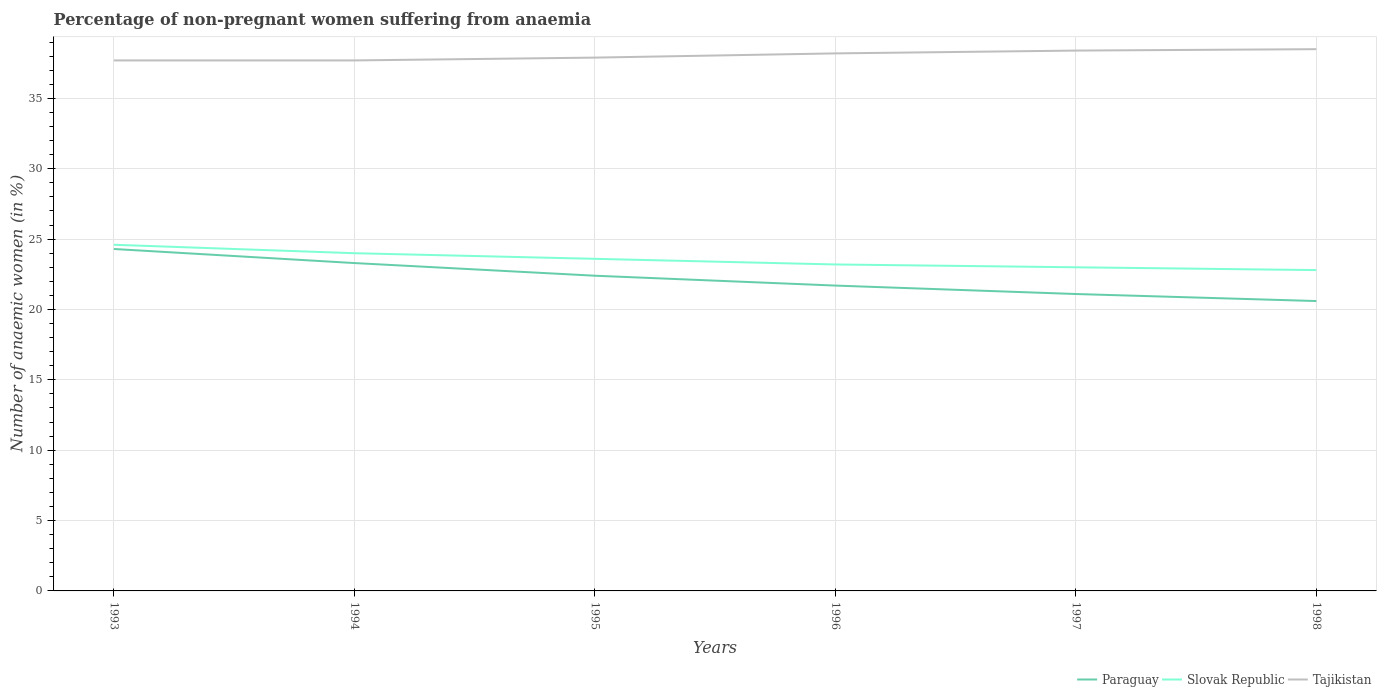Is the number of lines equal to the number of legend labels?
Give a very brief answer. Yes. Across all years, what is the maximum percentage of non-pregnant women suffering from anaemia in Paraguay?
Give a very brief answer. 20.6. In which year was the percentage of non-pregnant women suffering from anaemia in Slovak Republic maximum?
Keep it short and to the point. 1998. What is the total percentage of non-pregnant women suffering from anaemia in Paraguay in the graph?
Offer a terse response. 1.9. What is the difference between the highest and the second highest percentage of non-pregnant women suffering from anaemia in Slovak Republic?
Your answer should be compact. 1.8. What is the difference between the highest and the lowest percentage of non-pregnant women suffering from anaemia in Tajikistan?
Keep it short and to the point. 3. How many years are there in the graph?
Offer a terse response. 6. What is the difference between two consecutive major ticks on the Y-axis?
Your answer should be very brief. 5. Does the graph contain grids?
Offer a terse response. Yes. Where does the legend appear in the graph?
Keep it short and to the point. Bottom right. How many legend labels are there?
Your answer should be compact. 3. What is the title of the graph?
Ensure brevity in your answer.  Percentage of non-pregnant women suffering from anaemia. Does "Honduras" appear as one of the legend labels in the graph?
Make the answer very short. No. What is the label or title of the X-axis?
Your response must be concise. Years. What is the label or title of the Y-axis?
Offer a very short reply. Number of anaemic women (in %). What is the Number of anaemic women (in %) in Paraguay in 1993?
Make the answer very short. 24.3. What is the Number of anaemic women (in %) of Slovak Republic in 1993?
Make the answer very short. 24.6. What is the Number of anaemic women (in %) of Tajikistan in 1993?
Your answer should be very brief. 37.7. What is the Number of anaemic women (in %) of Paraguay in 1994?
Provide a short and direct response. 23.3. What is the Number of anaemic women (in %) in Tajikistan in 1994?
Make the answer very short. 37.7. What is the Number of anaemic women (in %) in Paraguay in 1995?
Your answer should be compact. 22.4. What is the Number of anaemic women (in %) in Slovak Republic in 1995?
Offer a terse response. 23.6. What is the Number of anaemic women (in %) in Tajikistan in 1995?
Offer a very short reply. 37.9. What is the Number of anaemic women (in %) of Paraguay in 1996?
Provide a short and direct response. 21.7. What is the Number of anaemic women (in %) of Slovak Republic in 1996?
Make the answer very short. 23.2. What is the Number of anaemic women (in %) in Tajikistan in 1996?
Your answer should be very brief. 38.2. What is the Number of anaemic women (in %) of Paraguay in 1997?
Keep it short and to the point. 21.1. What is the Number of anaemic women (in %) in Tajikistan in 1997?
Provide a short and direct response. 38.4. What is the Number of anaemic women (in %) of Paraguay in 1998?
Keep it short and to the point. 20.6. What is the Number of anaemic women (in %) of Slovak Republic in 1998?
Ensure brevity in your answer.  22.8. What is the Number of anaemic women (in %) of Tajikistan in 1998?
Provide a succinct answer. 38.5. Across all years, what is the maximum Number of anaemic women (in %) in Paraguay?
Your answer should be compact. 24.3. Across all years, what is the maximum Number of anaemic women (in %) in Slovak Republic?
Make the answer very short. 24.6. Across all years, what is the maximum Number of anaemic women (in %) of Tajikistan?
Your answer should be very brief. 38.5. Across all years, what is the minimum Number of anaemic women (in %) in Paraguay?
Keep it short and to the point. 20.6. Across all years, what is the minimum Number of anaemic women (in %) of Slovak Republic?
Give a very brief answer. 22.8. Across all years, what is the minimum Number of anaemic women (in %) of Tajikistan?
Your answer should be compact. 37.7. What is the total Number of anaemic women (in %) in Paraguay in the graph?
Your answer should be compact. 133.4. What is the total Number of anaemic women (in %) of Slovak Republic in the graph?
Your response must be concise. 141.2. What is the total Number of anaemic women (in %) of Tajikistan in the graph?
Make the answer very short. 228.4. What is the difference between the Number of anaemic women (in %) of Paraguay in 1993 and that in 1994?
Provide a short and direct response. 1. What is the difference between the Number of anaemic women (in %) in Slovak Republic in 1993 and that in 1995?
Make the answer very short. 1. What is the difference between the Number of anaemic women (in %) in Tajikistan in 1993 and that in 1996?
Give a very brief answer. -0.5. What is the difference between the Number of anaemic women (in %) in Paraguay in 1993 and that in 1997?
Make the answer very short. 3.2. What is the difference between the Number of anaemic women (in %) in Slovak Republic in 1993 and that in 1997?
Make the answer very short. 1.6. What is the difference between the Number of anaemic women (in %) of Tajikistan in 1993 and that in 1997?
Provide a short and direct response. -0.7. What is the difference between the Number of anaemic women (in %) in Slovak Republic in 1993 and that in 1998?
Your response must be concise. 1.8. What is the difference between the Number of anaemic women (in %) in Paraguay in 1994 and that in 1995?
Give a very brief answer. 0.9. What is the difference between the Number of anaemic women (in %) in Slovak Republic in 1994 and that in 1995?
Your answer should be compact. 0.4. What is the difference between the Number of anaemic women (in %) of Tajikistan in 1994 and that in 1996?
Provide a short and direct response. -0.5. What is the difference between the Number of anaemic women (in %) in Slovak Republic in 1994 and that in 1997?
Give a very brief answer. 1. What is the difference between the Number of anaemic women (in %) in Tajikistan in 1994 and that in 1997?
Your answer should be compact. -0.7. What is the difference between the Number of anaemic women (in %) in Tajikistan in 1994 and that in 1998?
Ensure brevity in your answer.  -0.8. What is the difference between the Number of anaemic women (in %) of Paraguay in 1995 and that in 1997?
Offer a very short reply. 1.3. What is the difference between the Number of anaemic women (in %) of Paraguay in 1995 and that in 1998?
Make the answer very short. 1.8. What is the difference between the Number of anaemic women (in %) in Slovak Republic in 1995 and that in 1998?
Ensure brevity in your answer.  0.8. What is the difference between the Number of anaemic women (in %) of Tajikistan in 1996 and that in 1997?
Your answer should be compact. -0.2. What is the difference between the Number of anaemic women (in %) in Slovak Republic in 1996 and that in 1998?
Your answer should be compact. 0.4. What is the difference between the Number of anaemic women (in %) of Paraguay in 1993 and the Number of anaemic women (in %) of Tajikistan in 1994?
Provide a succinct answer. -13.4. What is the difference between the Number of anaemic women (in %) in Slovak Republic in 1993 and the Number of anaemic women (in %) in Tajikistan in 1994?
Your response must be concise. -13.1. What is the difference between the Number of anaemic women (in %) in Paraguay in 1993 and the Number of anaemic women (in %) in Tajikistan in 1995?
Your response must be concise. -13.6. What is the difference between the Number of anaemic women (in %) in Slovak Republic in 1993 and the Number of anaemic women (in %) in Tajikistan in 1995?
Your answer should be compact. -13.3. What is the difference between the Number of anaemic women (in %) in Paraguay in 1993 and the Number of anaemic women (in %) in Slovak Republic in 1996?
Your response must be concise. 1.1. What is the difference between the Number of anaemic women (in %) in Slovak Republic in 1993 and the Number of anaemic women (in %) in Tajikistan in 1996?
Your answer should be very brief. -13.6. What is the difference between the Number of anaemic women (in %) of Paraguay in 1993 and the Number of anaemic women (in %) of Slovak Republic in 1997?
Offer a very short reply. 1.3. What is the difference between the Number of anaemic women (in %) of Paraguay in 1993 and the Number of anaemic women (in %) of Tajikistan in 1997?
Your response must be concise. -14.1. What is the difference between the Number of anaemic women (in %) of Slovak Republic in 1993 and the Number of anaemic women (in %) of Tajikistan in 1998?
Keep it short and to the point. -13.9. What is the difference between the Number of anaemic women (in %) in Paraguay in 1994 and the Number of anaemic women (in %) in Slovak Republic in 1995?
Provide a succinct answer. -0.3. What is the difference between the Number of anaemic women (in %) of Paraguay in 1994 and the Number of anaemic women (in %) of Tajikistan in 1995?
Ensure brevity in your answer.  -14.6. What is the difference between the Number of anaemic women (in %) of Slovak Republic in 1994 and the Number of anaemic women (in %) of Tajikistan in 1995?
Provide a succinct answer. -13.9. What is the difference between the Number of anaemic women (in %) of Paraguay in 1994 and the Number of anaemic women (in %) of Slovak Republic in 1996?
Keep it short and to the point. 0.1. What is the difference between the Number of anaemic women (in %) of Paraguay in 1994 and the Number of anaemic women (in %) of Tajikistan in 1996?
Your response must be concise. -14.9. What is the difference between the Number of anaemic women (in %) in Slovak Republic in 1994 and the Number of anaemic women (in %) in Tajikistan in 1996?
Make the answer very short. -14.2. What is the difference between the Number of anaemic women (in %) of Paraguay in 1994 and the Number of anaemic women (in %) of Slovak Republic in 1997?
Your answer should be very brief. 0.3. What is the difference between the Number of anaemic women (in %) of Paraguay in 1994 and the Number of anaemic women (in %) of Tajikistan in 1997?
Offer a very short reply. -15.1. What is the difference between the Number of anaemic women (in %) of Slovak Republic in 1994 and the Number of anaemic women (in %) of Tajikistan in 1997?
Your answer should be compact. -14.4. What is the difference between the Number of anaemic women (in %) of Paraguay in 1994 and the Number of anaemic women (in %) of Slovak Republic in 1998?
Provide a short and direct response. 0.5. What is the difference between the Number of anaemic women (in %) of Paraguay in 1994 and the Number of anaemic women (in %) of Tajikistan in 1998?
Make the answer very short. -15.2. What is the difference between the Number of anaemic women (in %) of Slovak Republic in 1994 and the Number of anaemic women (in %) of Tajikistan in 1998?
Provide a short and direct response. -14.5. What is the difference between the Number of anaemic women (in %) in Paraguay in 1995 and the Number of anaemic women (in %) in Tajikistan in 1996?
Make the answer very short. -15.8. What is the difference between the Number of anaemic women (in %) of Slovak Republic in 1995 and the Number of anaemic women (in %) of Tajikistan in 1996?
Provide a succinct answer. -14.6. What is the difference between the Number of anaemic women (in %) of Paraguay in 1995 and the Number of anaemic women (in %) of Slovak Republic in 1997?
Provide a short and direct response. -0.6. What is the difference between the Number of anaemic women (in %) in Paraguay in 1995 and the Number of anaemic women (in %) in Tajikistan in 1997?
Provide a succinct answer. -16. What is the difference between the Number of anaemic women (in %) in Slovak Republic in 1995 and the Number of anaemic women (in %) in Tajikistan in 1997?
Your answer should be compact. -14.8. What is the difference between the Number of anaemic women (in %) in Paraguay in 1995 and the Number of anaemic women (in %) in Slovak Republic in 1998?
Offer a very short reply. -0.4. What is the difference between the Number of anaemic women (in %) of Paraguay in 1995 and the Number of anaemic women (in %) of Tajikistan in 1998?
Your answer should be compact. -16.1. What is the difference between the Number of anaemic women (in %) in Slovak Republic in 1995 and the Number of anaemic women (in %) in Tajikistan in 1998?
Give a very brief answer. -14.9. What is the difference between the Number of anaemic women (in %) in Paraguay in 1996 and the Number of anaemic women (in %) in Slovak Republic in 1997?
Make the answer very short. -1.3. What is the difference between the Number of anaemic women (in %) of Paraguay in 1996 and the Number of anaemic women (in %) of Tajikistan in 1997?
Your answer should be compact. -16.7. What is the difference between the Number of anaemic women (in %) in Slovak Republic in 1996 and the Number of anaemic women (in %) in Tajikistan in 1997?
Provide a succinct answer. -15.2. What is the difference between the Number of anaemic women (in %) of Paraguay in 1996 and the Number of anaemic women (in %) of Tajikistan in 1998?
Your answer should be very brief. -16.8. What is the difference between the Number of anaemic women (in %) of Slovak Republic in 1996 and the Number of anaemic women (in %) of Tajikistan in 1998?
Ensure brevity in your answer.  -15.3. What is the difference between the Number of anaemic women (in %) of Paraguay in 1997 and the Number of anaemic women (in %) of Slovak Republic in 1998?
Offer a very short reply. -1.7. What is the difference between the Number of anaemic women (in %) in Paraguay in 1997 and the Number of anaemic women (in %) in Tajikistan in 1998?
Your answer should be compact. -17.4. What is the difference between the Number of anaemic women (in %) in Slovak Republic in 1997 and the Number of anaemic women (in %) in Tajikistan in 1998?
Give a very brief answer. -15.5. What is the average Number of anaemic women (in %) of Paraguay per year?
Your response must be concise. 22.23. What is the average Number of anaemic women (in %) in Slovak Republic per year?
Make the answer very short. 23.53. What is the average Number of anaemic women (in %) in Tajikistan per year?
Your answer should be very brief. 38.07. In the year 1993, what is the difference between the Number of anaemic women (in %) of Paraguay and Number of anaemic women (in %) of Slovak Republic?
Your answer should be very brief. -0.3. In the year 1993, what is the difference between the Number of anaemic women (in %) in Slovak Republic and Number of anaemic women (in %) in Tajikistan?
Provide a succinct answer. -13.1. In the year 1994, what is the difference between the Number of anaemic women (in %) in Paraguay and Number of anaemic women (in %) in Slovak Republic?
Give a very brief answer. -0.7. In the year 1994, what is the difference between the Number of anaemic women (in %) of Paraguay and Number of anaemic women (in %) of Tajikistan?
Make the answer very short. -14.4. In the year 1994, what is the difference between the Number of anaemic women (in %) of Slovak Republic and Number of anaemic women (in %) of Tajikistan?
Offer a terse response. -13.7. In the year 1995, what is the difference between the Number of anaemic women (in %) in Paraguay and Number of anaemic women (in %) in Slovak Republic?
Your answer should be compact. -1.2. In the year 1995, what is the difference between the Number of anaemic women (in %) in Paraguay and Number of anaemic women (in %) in Tajikistan?
Provide a short and direct response. -15.5. In the year 1995, what is the difference between the Number of anaemic women (in %) in Slovak Republic and Number of anaemic women (in %) in Tajikistan?
Ensure brevity in your answer.  -14.3. In the year 1996, what is the difference between the Number of anaemic women (in %) of Paraguay and Number of anaemic women (in %) of Tajikistan?
Your response must be concise. -16.5. In the year 1996, what is the difference between the Number of anaemic women (in %) of Slovak Republic and Number of anaemic women (in %) of Tajikistan?
Provide a succinct answer. -15. In the year 1997, what is the difference between the Number of anaemic women (in %) of Paraguay and Number of anaemic women (in %) of Tajikistan?
Give a very brief answer. -17.3. In the year 1997, what is the difference between the Number of anaemic women (in %) in Slovak Republic and Number of anaemic women (in %) in Tajikistan?
Provide a short and direct response. -15.4. In the year 1998, what is the difference between the Number of anaemic women (in %) in Paraguay and Number of anaemic women (in %) in Tajikistan?
Keep it short and to the point. -17.9. In the year 1998, what is the difference between the Number of anaemic women (in %) of Slovak Republic and Number of anaemic women (in %) of Tajikistan?
Provide a short and direct response. -15.7. What is the ratio of the Number of anaemic women (in %) in Paraguay in 1993 to that in 1994?
Offer a very short reply. 1.04. What is the ratio of the Number of anaemic women (in %) of Slovak Republic in 1993 to that in 1994?
Offer a terse response. 1.02. What is the ratio of the Number of anaemic women (in %) in Tajikistan in 1993 to that in 1994?
Ensure brevity in your answer.  1. What is the ratio of the Number of anaemic women (in %) in Paraguay in 1993 to that in 1995?
Your answer should be very brief. 1.08. What is the ratio of the Number of anaemic women (in %) in Slovak Republic in 1993 to that in 1995?
Offer a very short reply. 1.04. What is the ratio of the Number of anaemic women (in %) of Paraguay in 1993 to that in 1996?
Ensure brevity in your answer.  1.12. What is the ratio of the Number of anaemic women (in %) of Slovak Republic in 1993 to that in 1996?
Keep it short and to the point. 1.06. What is the ratio of the Number of anaemic women (in %) of Tajikistan in 1993 to that in 1996?
Your answer should be compact. 0.99. What is the ratio of the Number of anaemic women (in %) of Paraguay in 1993 to that in 1997?
Your response must be concise. 1.15. What is the ratio of the Number of anaemic women (in %) in Slovak Republic in 1993 to that in 1997?
Keep it short and to the point. 1.07. What is the ratio of the Number of anaemic women (in %) of Tajikistan in 1993 to that in 1997?
Offer a very short reply. 0.98. What is the ratio of the Number of anaemic women (in %) of Paraguay in 1993 to that in 1998?
Offer a terse response. 1.18. What is the ratio of the Number of anaemic women (in %) of Slovak Republic in 1993 to that in 1998?
Your response must be concise. 1.08. What is the ratio of the Number of anaemic women (in %) in Tajikistan in 1993 to that in 1998?
Provide a short and direct response. 0.98. What is the ratio of the Number of anaemic women (in %) of Paraguay in 1994 to that in 1995?
Your answer should be compact. 1.04. What is the ratio of the Number of anaemic women (in %) of Slovak Republic in 1994 to that in 1995?
Make the answer very short. 1.02. What is the ratio of the Number of anaemic women (in %) of Tajikistan in 1994 to that in 1995?
Your answer should be very brief. 0.99. What is the ratio of the Number of anaemic women (in %) of Paraguay in 1994 to that in 1996?
Your answer should be very brief. 1.07. What is the ratio of the Number of anaemic women (in %) of Slovak Republic in 1994 to that in 1996?
Offer a terse response. 1.03. What is the ratio of the Number of anaemic women (in %) in Tajikistan in 1994 to that in 1996?
Your response must be concise. 0.99. What is the ratio of the Number of anaemic women (in %) of Paraguay in 1994 to that in 1997?
Make the answer very short. 1.1. What is the ratio of the Number of anaemic women (in %) of Slovak Republic in 1994 to that in 1997?
Ensure brevity in your answer.  1.04. What is the ratio of the Number of anaemic women (in %) in Tajikistan in 1994 to that in 1997?
Provide a succinct answer. 0.98. What is the ratio of the Number of anaemic women (in %) of Paraguay in 1994 to that in 1998?
Make the answer very short. 1.13. What is the ratio of the Number of anaemic women (in %) of Slovak Republic in 1994 to that in 1998?
Give a very brief answer. 1.05. What is the ratio of the Number of anaemic women (in %) in Tajikistan in 1994 to that in 1998?
Ensure brevity in your answer.  0.98. What is the ratio of the Number of anaemic women (in %) of Paraguay in 1995 to that in 1996?
Ensure brevity in your answer.  1.03. What is the ratio of the Number of anaemic women (in %) of Slovak Republic in 1995 to that in 1996?
Provide a short and direct response. 1.02. What is the ratio of the Number of anaemic women (in %) in Paraguay in 1995 to that in 1997?
Provide a short and direct response. 1.06. What is the ratio of the Number of anaemic women (in %) of Slovak Republic in 1995 to that in 1997?
Your response must be concise. 1.03. What is the ratio of the Number of anaemic women (in %) of Paraguay in 1995 to that in 1998?
Offer a very short reply. 1.09. What is the ratio of the Number of anaemic women (in %) in Slovak Republic in 1995 to that in 1998?
Your answer should be compact. 1.04. What is the ratio of the Number of anaemic women (in %) in Tajikistan in 1995 to that in 1998?
Offer a very short reply. 0.98. What is the ratio of the Number of anaemic women (in %) in Paraguay in 1996 to that in 1997?
Your answer should be very brief. 1.03. What is the ratio of the Number of anaemic women (in %) in Slovak Republic in 1996 to that in 1997?
Ensure brevity in your answer.  1.01. What is the ratio of the Number of anaemic women (in %) in Tajikistan in 1996 to that in 1997?
Provide a short and direct response. 0.99. What is the ratio of the Number of anaemic women (in %) of Paraguay in 1996 to that in 1998?
Provide a succinct answer. 1.05. What is the ratio of the Number of anaemic women (in %) of Slovak Republic in 1996 to that in 1998?
Offer a terse response. 1.02. What is the ratio of the Number of anaemic women (in %) in Paraguay in 1997 to that in 1998?
Offer a very short reply. 1.02. What is the ratio of the Number of anaemic women (in %) of Slovak Republic in 1997 to that in 1998?
Provide a succinct answer. 1.01. What is the ratio of the Number of anaemic women (in %) in Tajikistan in 1997 to that in 1998?
Make the answer very short. 1. What is the difference between the highest and the second highest Number of anaemic women (in %) of Slovak Republic?
Offer a very short reply. 0.6. What is the difference between the highest and the second highest Number of anaemic women (in %) in Tajikistan?
Provide a short and direct response. 0.1. What is the difference between the highest and the lowest Number of anaemic women (in %) of Paraguay?
Your answer should be very brief. 3.7. What is the difference between the highest and the lowest Number of anaemic women (in %) of Slovak Republic?
Your response must be concise. 1.8. What is the difference between the highest and the lowest Number of anaemic women (in %) in Tajikistan?
Make the answer very short. 0.8. 